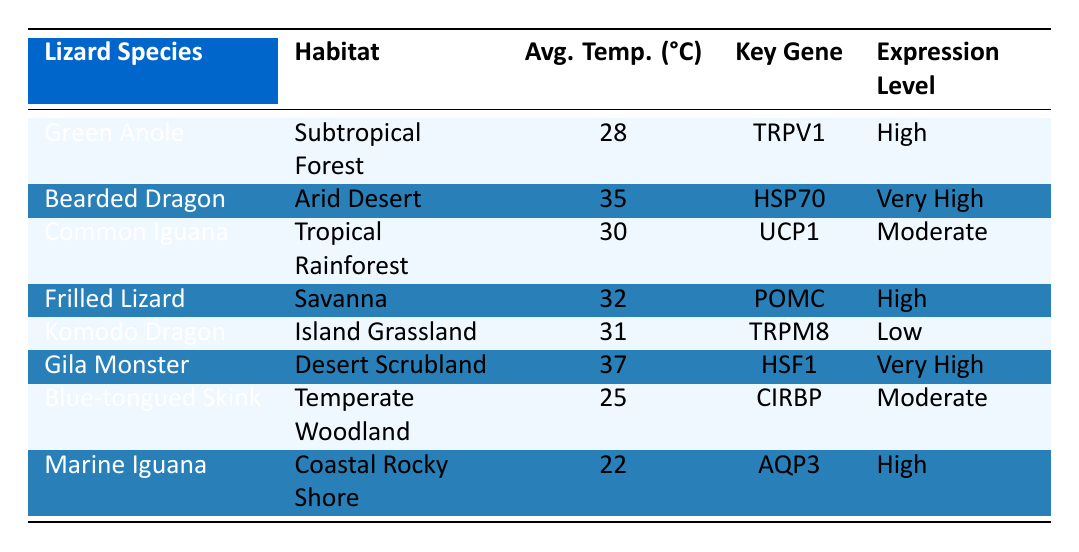What is the expression level of the Green Anole? The table specifies that the Green Anole has an expression level of "High." It is directly referenced in the row corresponding to this species.
Answer: High Which lizard species has the highest average temperature habitat? By examining the "Average Temperature (°C)" column, the Bearded Dragon is listed with the highest temperature of 35°C in the "Arid Desert" habitat. Hence, it holds the highest average temperature.
Answer: Bearded Dragon Are there any lizard species with low expression levels? From the table, the Komodo Dragon is identified with a "Low" expression level corresponding to its habitat. Other species either have moderate, high, or very high expression levels.
Answer: Yes What is the average temperature of habitats for lizards with very high gene expression? The habitats with very high gene expression are for the Bearded Dragon (35°C) and Gila Monster (37°C). Adding these temperatures gives 72°C, and dividing by 2 (since there are 2 species) results in an average temperature of 36°C.
Answer: 36°C Is the POMC gene associated with a higher average temperature than the UCP1 gene? The POMC gene belongs to the Frilled Lizard in the Savanna habitat (32°C) while the UCP1 gene is in the Common Iguana from the Tropical Rainforest (30°C). Since 32°C is greater than 30°C, the POMC gene is associated with a higher temperature.
Answer: Yes Which habitat has the lowest average temperature for lizards? Checking the "Average Temperature (°C)" column, the Marine Iguana inhabits the "Coastal Rocky Shore" with an average temperature of 22°C, which is the lowest compared to other lizards listed.
Answer: Coastal Rocky Shore How many lizard species are found in habitats with high expression levels? The lizard species with high expression levels are the Green Anole (High), Frilled Lizard (High), and Marine Iguana (High). Thus, there are three species listed with high expression levels in their respective habitats.
Answer: 3 Which lizard species lives in the coolest habitat and has a moderate expression level? Referring to the table, the Blue-tongued Skink with a "Temperate Woodland" habitat has an average temperature of 25°C and a moderate expression level. This makes it the coolest species with moderate expression.
Answer: Blue-tongued Skink What is the key thermoregulation gene for the Gila Monster? The Gila Monster's row shows that its key thermoregulation gene is "HSF1." This is directly found in the corresponding row for this species.
Answer: HSF1 